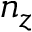<formula> <loc_0><loc_0><loc_500><loc_500>n _ { z }</formula> 